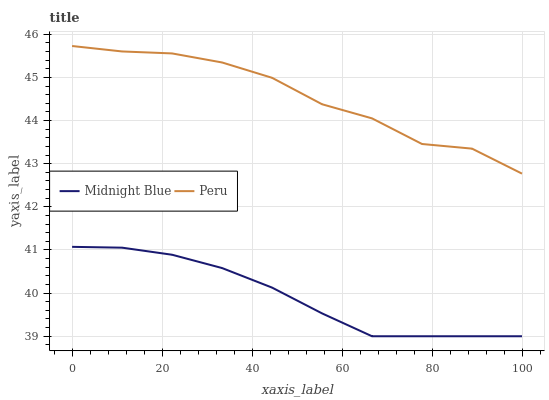Does Midnight Blue have the minimum area under the curve?
Answer yes or no. Yes. Does Peru have the maximum area under the curve?
Answer yes or no. Yes. Does Peru have the minimum area under the curve?
Answer yes or no. No. Is Midnight Blue the smoothest?
Answer yes or no. Yes. Is Peru the roughest?
Answer yes or no. Yes. Is Peru the smoothest?
Answer yes or no. No. Does Midnight Blue have the lowest value?
Answer yes or no. Yes. Does Peru have the lowest value?
Answer yes or no. No. Does Peru have the highest value?
Answer yes or no. Yes. Is Midnight Blue less than Peru?
Answer yes or no. Yes. Is Peru greater than Midnight Blue?
Answer yes or no. Yes. Does Midnight Blue intersect Peru?
Answer yes or no. No. 